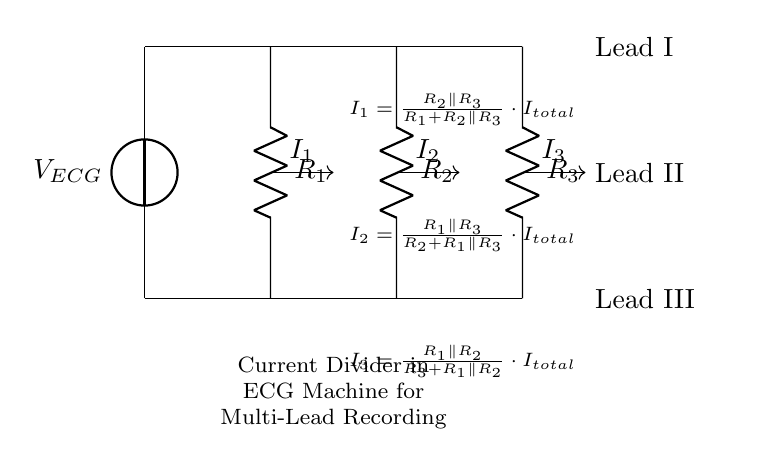What is the total current in the circuit? The total current is represented as I total in the diagram. While the exact numerical value is not provided within the visual information, it indicates the sum of the currents flowing through all branches of the current divider.
Answer: I total What are the resistances in the circuit? The resistances shown in the circuit are R1, R2, and R3. These values are critical for determining how the total current is divided among the branches in the current divider configuration.
Answer: R1, R2, R3 Which lead corresponds to current I1? Lead I corresponds to current I1 in the circuit diagram. The layout clearly indicates that the current I1 flows through the resistor R1, thus leading to Lead I.
Answer: Lead I How is the current I2 calculated in the circuit? The current I2 is calculated using the formula I2 = (R1 parallel R3) / (R2 + R1 parallel R3) * I total. This equation indicates the dependence of current I2 on the resistor values and total current in the circuit.
Answer: I2 formula What is the relationship between R2 and the lead associated with I3? Resistor R2 is not directly part of the path for current I3, which flows through R1 and R2 in parallel to R3. Thus, R2’s value indirectly affects but does not participate in the current I3 calculation directly.
Answer: Indirect relationship What does the parallel resistor notation R2 parallel R3 imply? The parallel notation indicates that the resistors R2 and R3 are connected in parallel, meaning that the total resistance for that part of the circuit can be calculated using the parallel resistor formula. This configuration affects how the total current is divided among the resistors.
Answer: Resistors in parallel Which lead shows the largest current output? The lead with the largest current output can be determined based on the values of the resistors; generally, it is the lead associated with the lowest resistance in the parallel configuration when I total is constant. However, without specific values, the lead cannot be definitively identified.
Answer: Depends on resistance values 